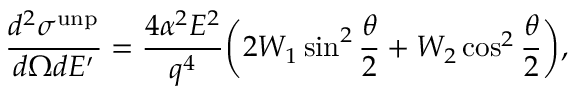<formula> <loc_0><loc_0><loc_500><loc_500>\frac { d ^ { 2 } \sigma ^ { u n p } } { d \Omega d E ^ { \prime } } = \frac { 4 \alpha ^ { 2 } E ^ { 2 } } { q ^ { 4 } } \left ( 2 W _ { 1 } \sin ^ { 2 } \frac { \theta } { 2 } + W _ { 2 } \cos ^ { 2 } \frac { \theta } { 2 } \right ) ,</formula> 